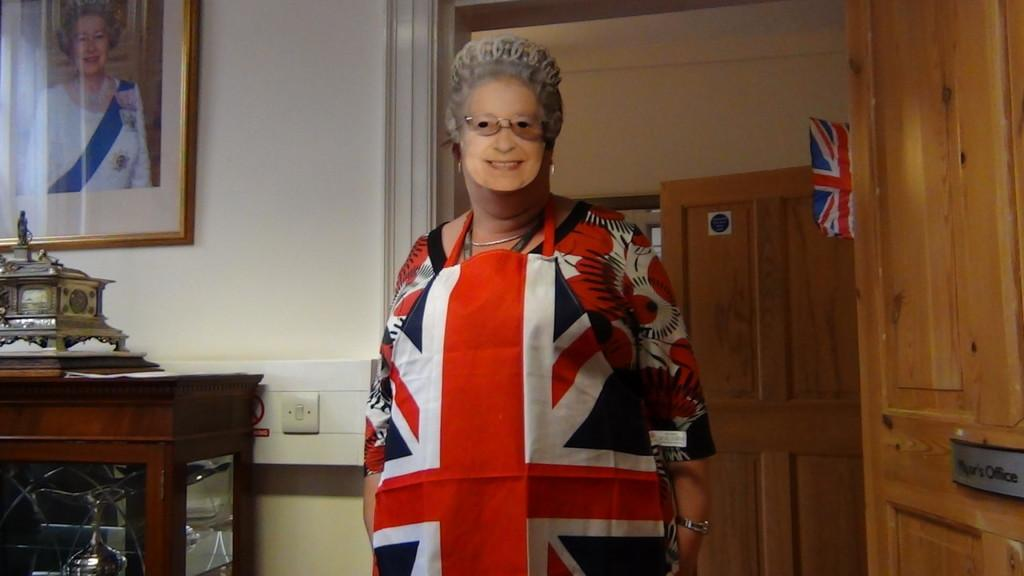Who is present in the image? There is a woman in the image. What is the woman wearing on her face? The woman is wearing a mask on her face. What type of fruit is the woman holding in the image? There is no fruit present in the image; the woman is wearing a mask on her face. 